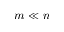Convert formula to latex. <formula><loc_0><loc_0><loc_500><loc_500>m \ll n</formula> 